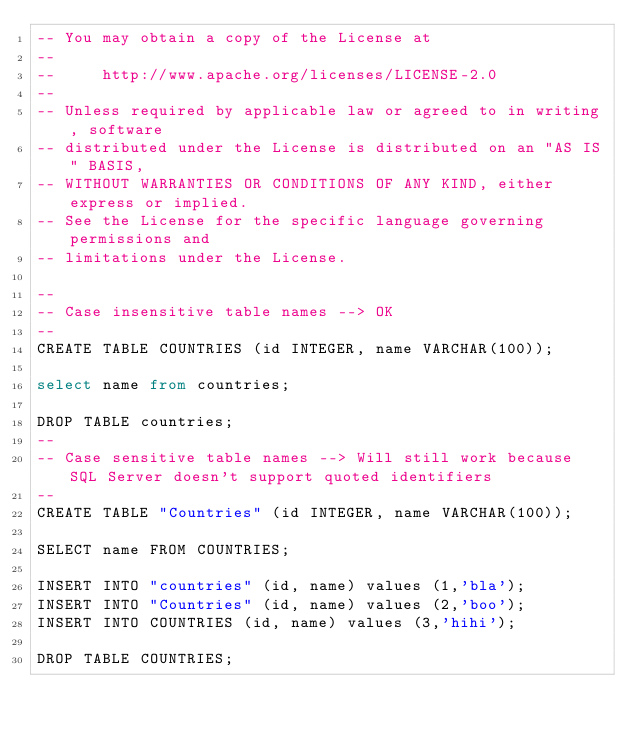<code> <loc_0><loc_0><loc_500><loc_500><_SQL_>-- You may obtain a copy of the License at
--
--     http://www.apache.org/licenses/LICENSE-2.0
--
-- Unless required by applicable law or agreed to in writing, software
-- distributed under the License is distributed on an "AS IS" BASIS,
-- WITHOUT WARRANTIES OR CONDITIONS OF ANY KIND, either express or implied.
-- See the License for the specific language governing permissions and
-- limitations under the License.

--
-- Case insensitive table names --> OK
--
CREATE TABLE COUNTRIES (id INTEGER, name VARCHAR(100));

select name from countries;

DROP TABLE countries;
--
-- Case sensitive table names --> Will still work because SQL Server doesn't support quoted identifiers
--
CREATE TABLE "Countries" (id INTEGER, name VARCHAR(100));

SELECT name FROM COUNTRIES;

INSERT INTO "countries" (id, name) values (1,'bla');
INSERT INTO "Countries" (id, name) values (2,'boo');
INSERT INTO COUNTRIES (id, name) values (3,'hihi');

DROP TABLE COUNTRIES;
</code> 